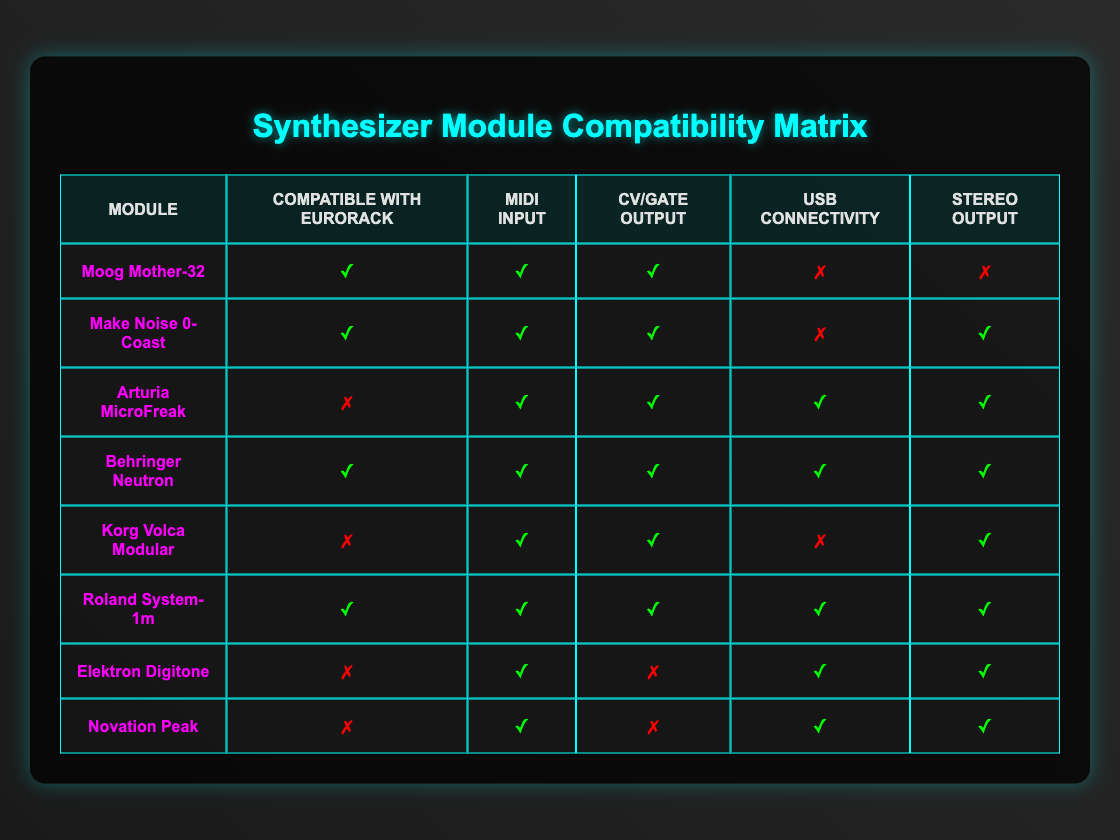What synthesizers are compatible with Eurorack? To find the synthesizers compatible with Eurorack, we look for a check mark (✓) under the "Compatible with Eurorack" column. These synthesizers are: Moog Mother-32, Make Noise 0-Coast, Behringer Neutron, Roland System-1m.
Answer: Moog Mother-32, Make Noise 0-Coast, Behringer Neutron, Roland System-1m Which synthesizer has USB connectivity but is not compatible with Eurorack? We need to identify synthesizers that have a check mark (✓) under "USB connectivity" but a cross (✗) under "Compatible with Eurorack." The only synthesizers that fit this criterion are Arturia MicroFreak, Elektron Digitone, and Novation Peak.
Answer: Arturia MicroFreak, Elektron Digitone, Novation Peak How many synthesizers have both MIDI input and CV/Gate output? Count the rows that have check marks (✓) under both "MIDI input" and "CV/Gate output." There are a total of five such synthesizers: Make Noise 0-Coast, Arturia MicroFreak, Behringer Neutron, Korg Volca Modular, and Roland System-1m.
Answer: 5 Is the Korg Volca Modular compatible with USB connectivity? To find out, we check the row for Korg Volca Modular under the "USB connectivity" column. There is a cross (✗), indicating it is not compatible with USB connectivity.
Answer: No Which synthesizer offers the most connectivity options overall? To determine this, we need to count the check marks (✓) for each synthesizer across all compatibility options. Behringer Neutron and Roland System-1m both have five check marks (✓) each, indicating they offer full connectivity options.
Answer: Behringer Neutron and Roland System-1m 